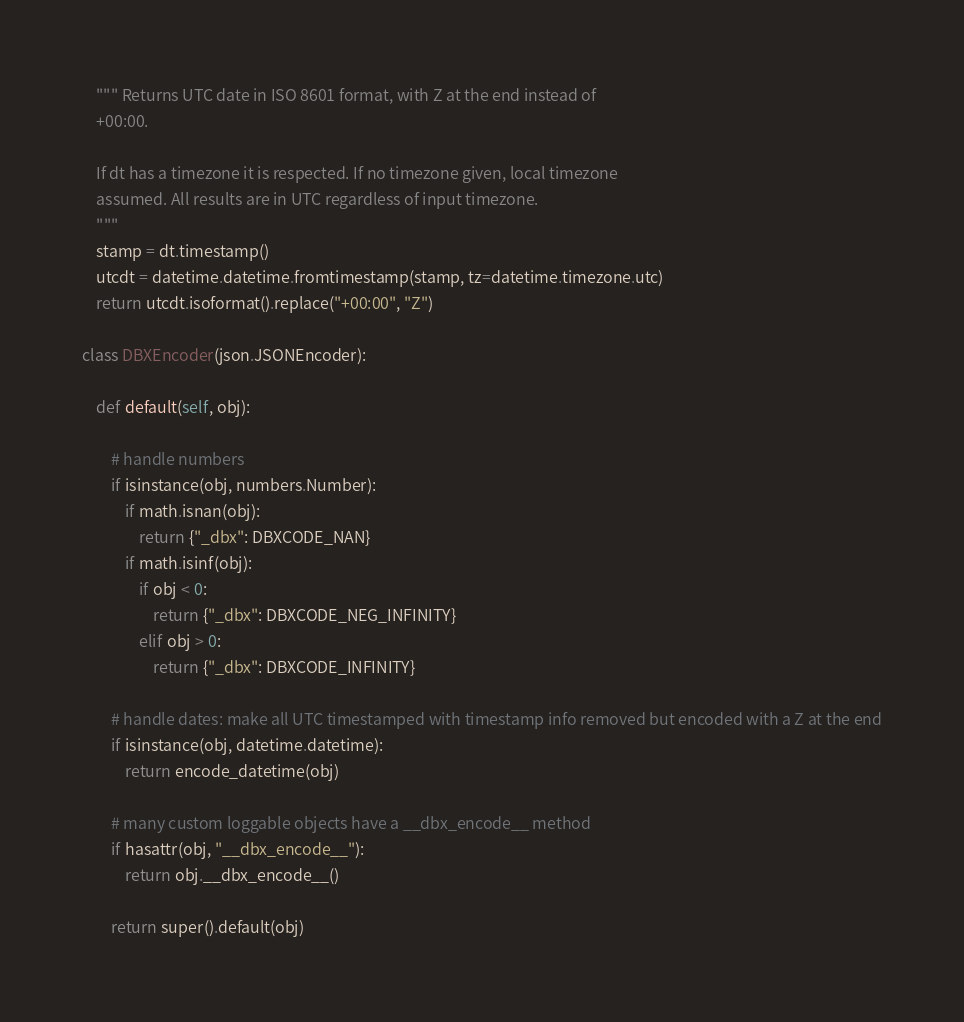<code> <loc_0><loc_0><loc_500><loc_500><_Python_>    """ Returns UTC date in ISO 8601 format, with Z at the end instead of
    +00:00.

    If dt has a timezone it is respected. If no timezone given, local timezone
    assumed. All results are in UTC regardless of input timezone.
    """
    stamp = dt.timestamp()
    utcdt = datetime.datetime.fromtimestamp(stamp, tz=datetime.timezone.utc)
    return utcdt.isoformat().replace("+00:00", "Z")

class DBXEncoder(json.JSONEncoder):

    def default(self, obj):

        # handle numbers
        if isinstance(obj, numbers.Number):
            if math.isnan(obj):
                return {"_dbx": DBXCODE_NAN}
            if math.isinf(obj):
                if obj < 0:
                    return {"_dbx": DBXCODE_NEG_INFINITY}
                elif obj > 0:
                    return {"_dbx": DBXCODE_INFINITY}

        # handle dates: make all UTC timestamped with timestamp info removed but encoded with a Z at the end
        if isinstance(obj, datetime.datetime):
            return encode_datetime(obj)

        # many custom loggable objects have a __dbx_encode__ method
        if hasattr(obj, "__dbx_encode__"):
            return obj.__dbx_encode__()

        return super().default(obj)
</code> 